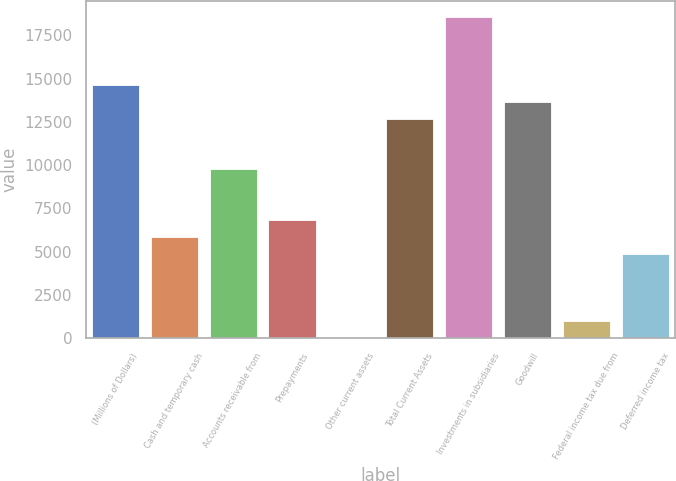<chart> <loc_0><loc_0><loc_500><loc_500><bar_chart><fcel>(Millions of Dollars)<fcel>Cash and temporary cash<fcel>Accounts receivable from<fcel>Prepayments<fcel>Other current assets<fcel>Total Current Assets<fcel>Investments in subsidiaries<fcel>Goodwill<fcel>Federal income tax due from<fcel>Deferred income tax<nl><fcel>14639.5<fcel>5858.2<fcel>9761<fcel>6833.9<fcel>4<fcel>12688.1<fcel>18542.3<fcel>13663.8<fcel>979.7<fcel>4882.5<nl></chart> 